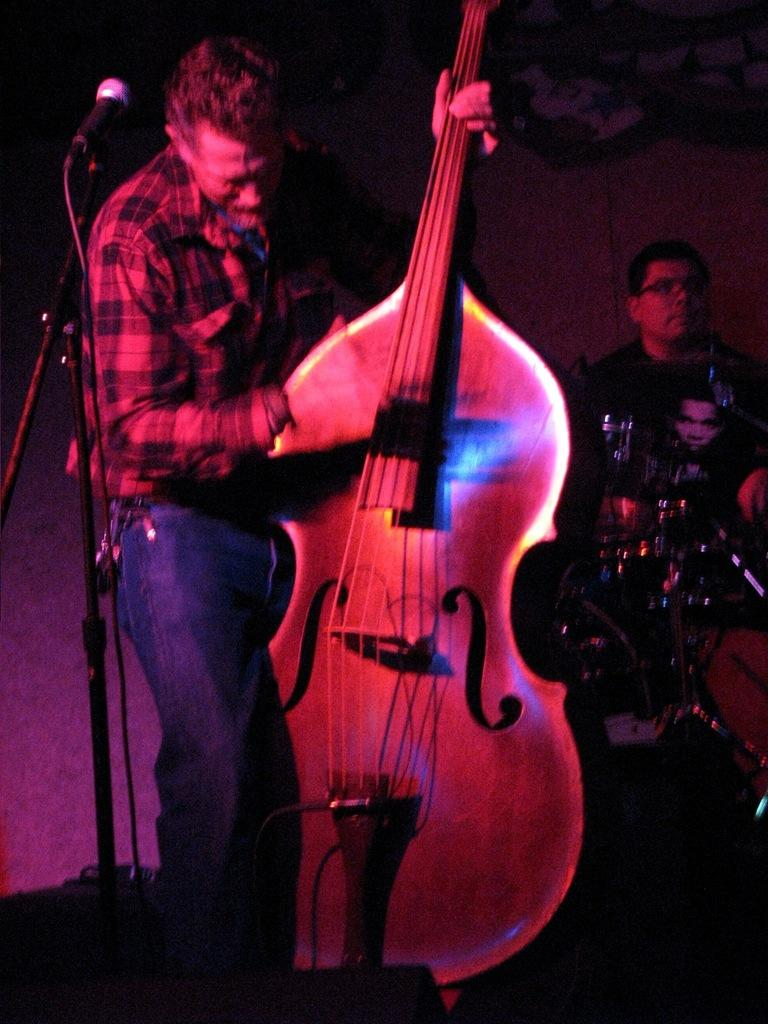What is the person in the image holding? The person is holding a guitar in the image. What can be seen in front of the person holding the guitar? The person is standing in front of a microphone. What is happening in the background of the image? There is a person hitting drums in the background of the image. What type of grass is growing near the person playing the drums? There is no grass visible in the image; it is an indoor setting with a person playing drums in the background. 